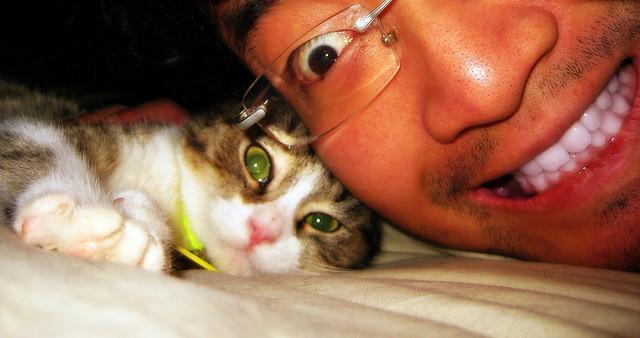How many beds can you see?
Give a very brief answer. 1. How many birds are there?
Give a very brief answer. 0. 